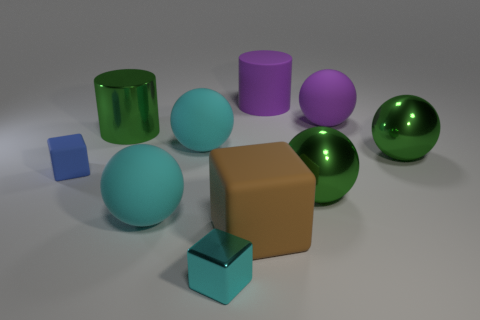Subtract all purple balls. How many balls are left? 4 Subtract all big purple matte spheres. How many spheres are left? 4 Subtract 1 spheres. How many spheres are left? 4 Subtract all gray balls. Subtract all yellow cylinders. How many balls are left? 5 Subtract all blocks. How many objects are left? 7 Add 1 green balls. How many green balls are left? 3 Add 7 small rubber things. How many small rubber things exist? 8 Subtract 1 brown blocks. How many objects are left? 9 Subtract all large green things. Subtract all large cylinders. How many objects are left? 5 